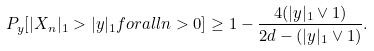<formula> <loc_0><loc_0><loc_500><loc_500>P _ { y } [ | X _ { n } | _ { 1 } > | y | _ { 1 } f o r a l l n > 0 ] \geq 1 - \frac { 4 ( | y | _ { 1 } \vee 1 ) } { 2 d - ( | y | _ { 1 } \vee 1 ) } .</formula> 